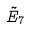<formula> <loc_0><loc_0><loc_500><loc_500>\tilde { E } _ { 7 }</formula> 